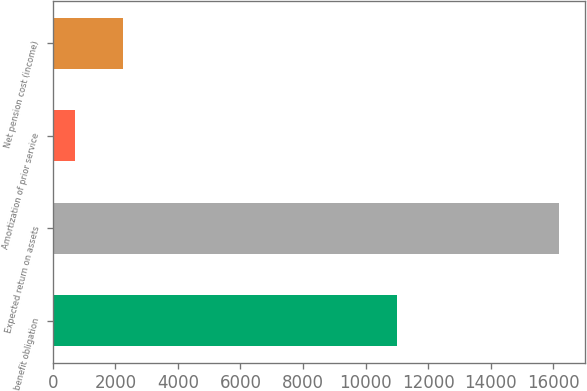<chart> <loc_0><loc_0><loc_500><loc_500><bar_chart><fcel>benefit obligation<fcel>Expected return on assets<fcel>Amortization of prior service<fcel>Net pension cost (income)<nl><fcel>11013<fcel>16197<fcel>705<fcel>2254.2<nl></chart> 